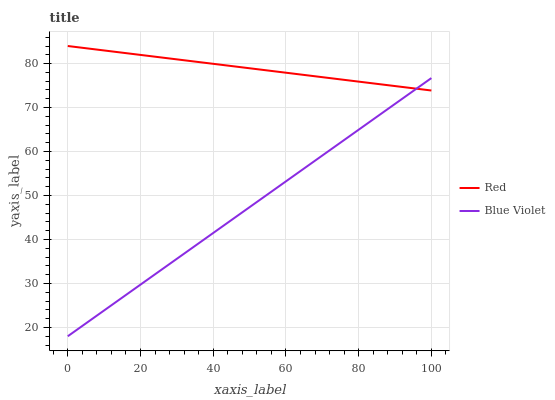Does Blue Violet have the minimum area under the curve?
Answer yes or no. Yes. Does Red have the maximum area under the curve?
Answer yes or no. Yes. Does Red have the minimum area under the curve?
Answer yes or no. No. Is Blue Violet the smoothest?
Answer yes or no. Yes. Is Red the roughest?
Answer yes or no. Yes. Is Red the smoothest?
Answer yes or no. No. Does Blue Violet have the lowest value?
Answer yes or no. Yes. Does Red have the lowest value?
Answer yes or no. No. Does Red have the highest value?
Answer yes or no. Yes. Does Red intersect Blue Violet?
Answer yes or no. Yes. Is Red less than Blue Violet?
Answer yes or no. No. Is Red greater than Blue Violet?
Answer yes or no. No. 